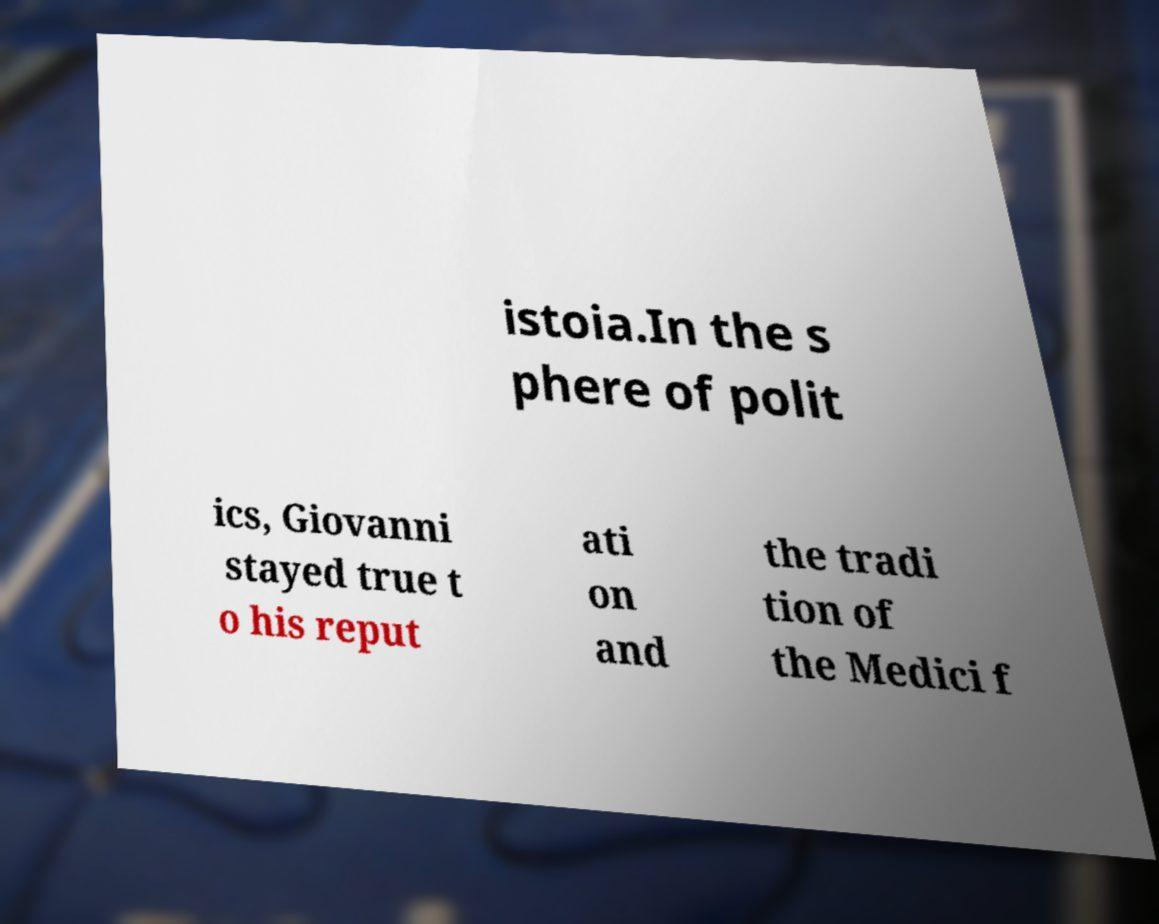What messages or text are displayed in this image? I need them in a readable, typed format. istoia.In the s phere of polit ics, Giovanni stayed true t o his reput ati on and the tradi tion of the Medici f 